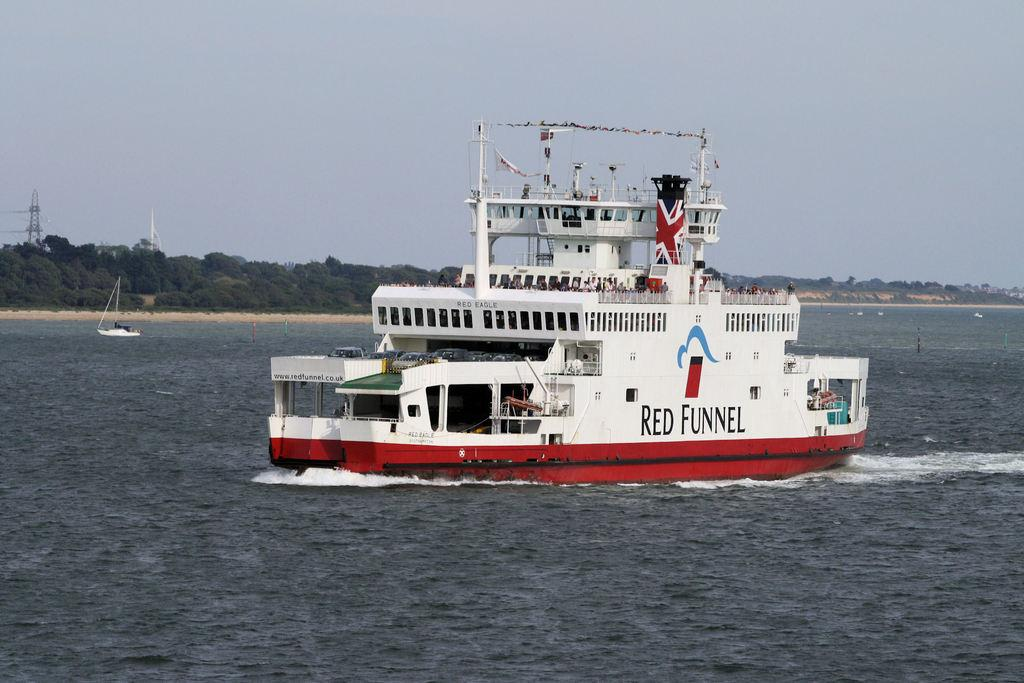What type of vehicle is in the image? There is a ferry in the image. What is the ferry doing in the image? The ferry is moving on the water. Are there any other watercraft in the image? Yes, there is a boat in the image. What can be seen in the background of the image? Trees and a transmission tower are visible in the image. What is visible above the water and trees in the image? The sky is visible in the image. How many goldfish are swimming in the water near the ferry? There are no goldfish visible in the image; it only features a ferry, a boat, trees, a transmission tower, and the sky. 